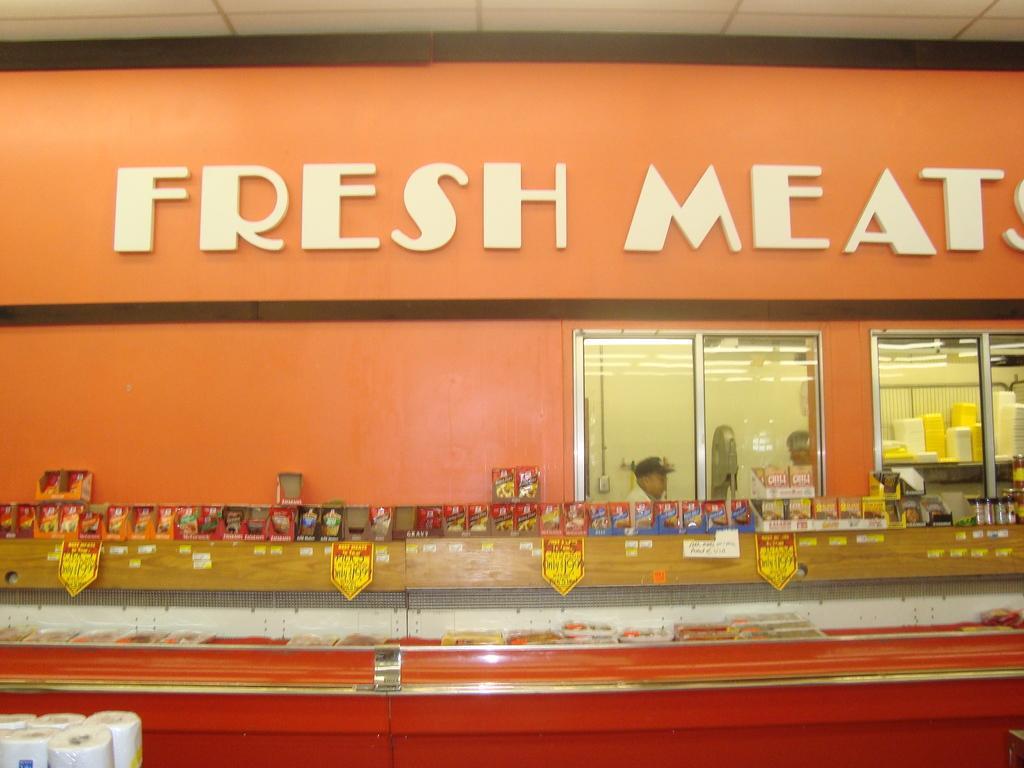Please provide a concise description of this image. We can see tissue rolls,objects on the red surface,boards and stickers on wooden surface and few objects on the surface. In the background we can see wall and glass windows,through these windows we can see people,wall,lights and objects. 